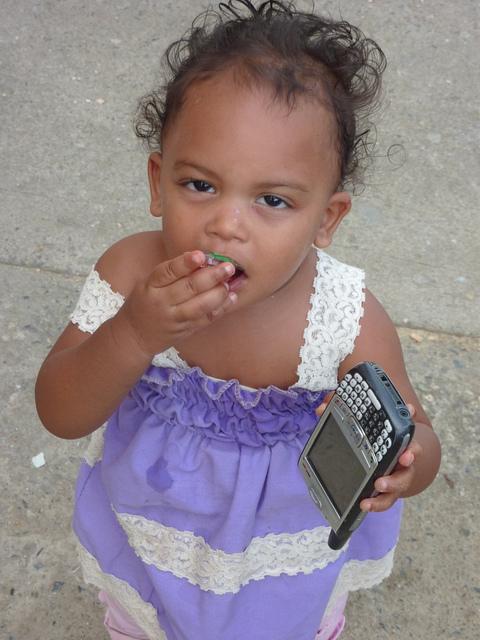What is the girl putting in her mouth?
Concise answer only. Candy. What is in the girl's left hand?
Concise answer only. Phone. Is this girl talking?
Keep it brief. No. 